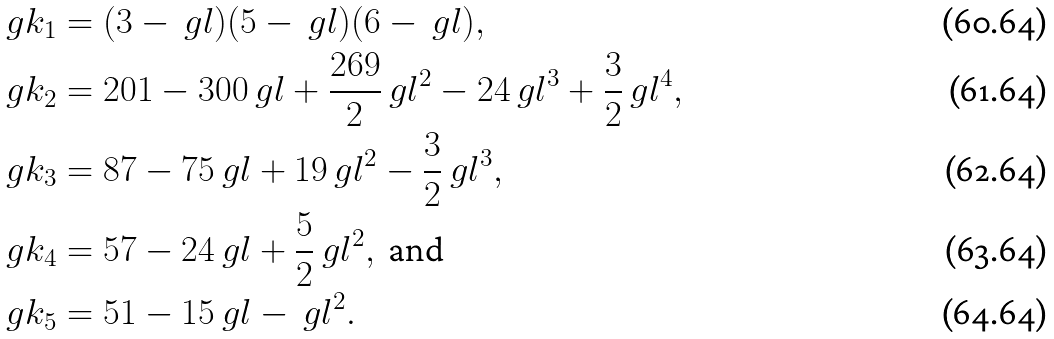Convert formula to latex. <formula><loc_0><loc_0><loc_500><loc_500>\ g k _ { 1 } & = ( 3 - \ g l ) ( 5 - \ g l ) ( 6 - \ g l ) , \\ \ g k _ { 2 } & = 2 0 1 - 3 0 0 \ g l + \frac { 2 6 9 } { 2 } \ g l ^ { 2 } - 2 4 \ g l ^ { 3 } + \frac { 3 } { 2 } \ g l ^ { 4 } , \\ \ g k _ { 3 } & = 8 7 - 7 5 \ g l + 1 9 \ g l ^ { 2 } - \frac { 3 } { 2 } \ g l ^ { 3 } , \\ \ g k _ { 4 } & = 5 7 - 2 4 \ g l + \frac { 5 } { 2 } \ g l ^ { 2 } , \text { and} \\ \ g k _ { 5 } & = 5 1 - 1 5 \ g l - \ g l ^ { 2 } .</formula> 